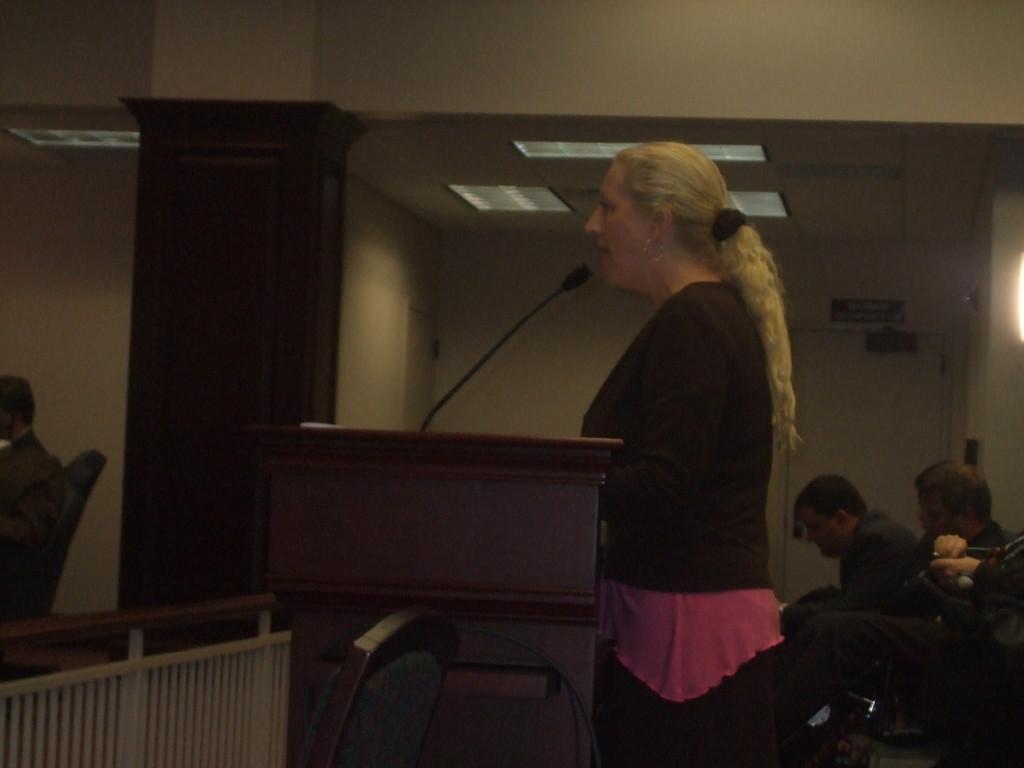Could you give a brief overview of what you see in this image? In this picture there is a woman standing behind the podium. There is a microphone on the podium. On the right side of the image there are group of people sitting. On the left side of the image there is a person sitting. In the foreground there is a chair and there is a railing. At the back there is a door at the top there are lights. 